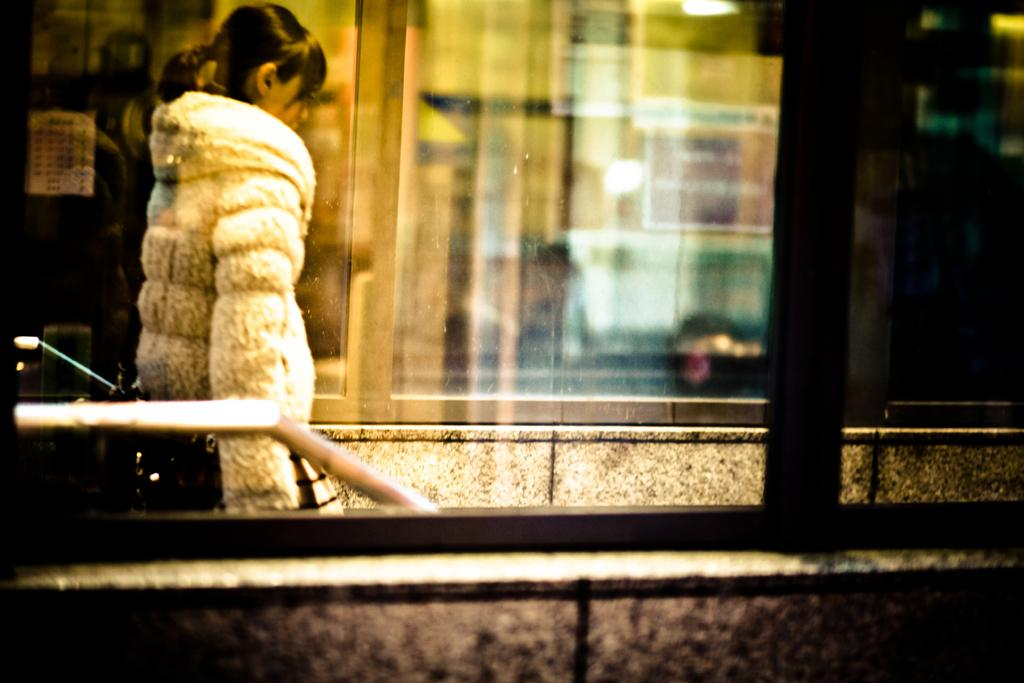Who is the main subject in the image? There is a woman in the image. What is the woman wearing? The woman is wearing a coat. What is the woman doing in the image? The woman is standing. What can be seen in the background of the image? There are windows and poles in the background of the image. What verse is the woman reciting in the image? There is no indication in the image that the woman is reciting a verse, so it cannot be determined from the picture. 